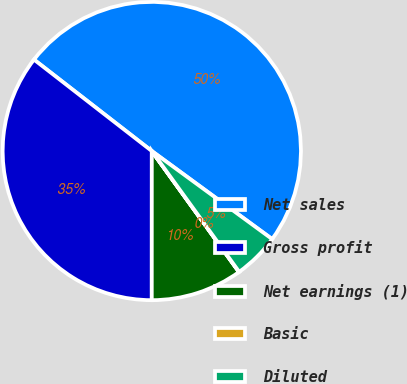Convert chart to OTSL. <chart><loc_0><loc_0><loc_500><loc_500><pie_chart><fcel>Net sales<fcel>Gross profit<fcel>Net earnings (1)<fcel>Basic<fcel>Diluted<nl><fcel>49.55%<fcel>35.5%<fcel>9.94%<fcel>0.03%<fcel>4.98%<nl></chart> 